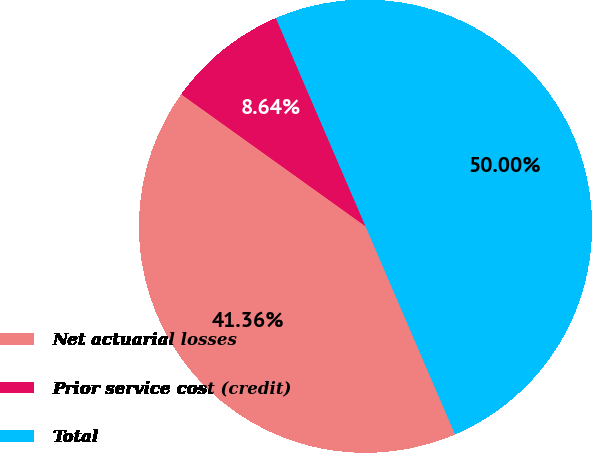Convert chart to OTSL. <chart><loc_0><loc_0><loc_500><loc_500><pie_chart><fcel>Net actuarial losses<fcel>Prior service cost (credit)<fcel>Total<nl><fcel>41.36%<fcel>8.64%<fcel>50.0%<nl></chart> 